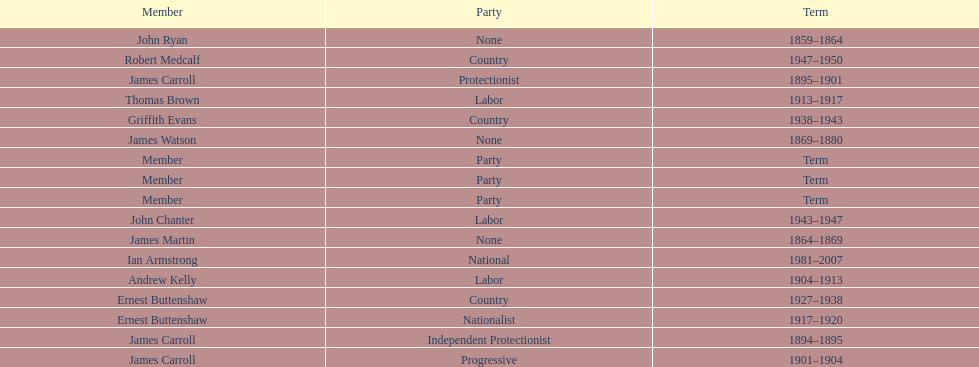How long did the fourth incarnation of the lachlan exist? 1981-2007. 